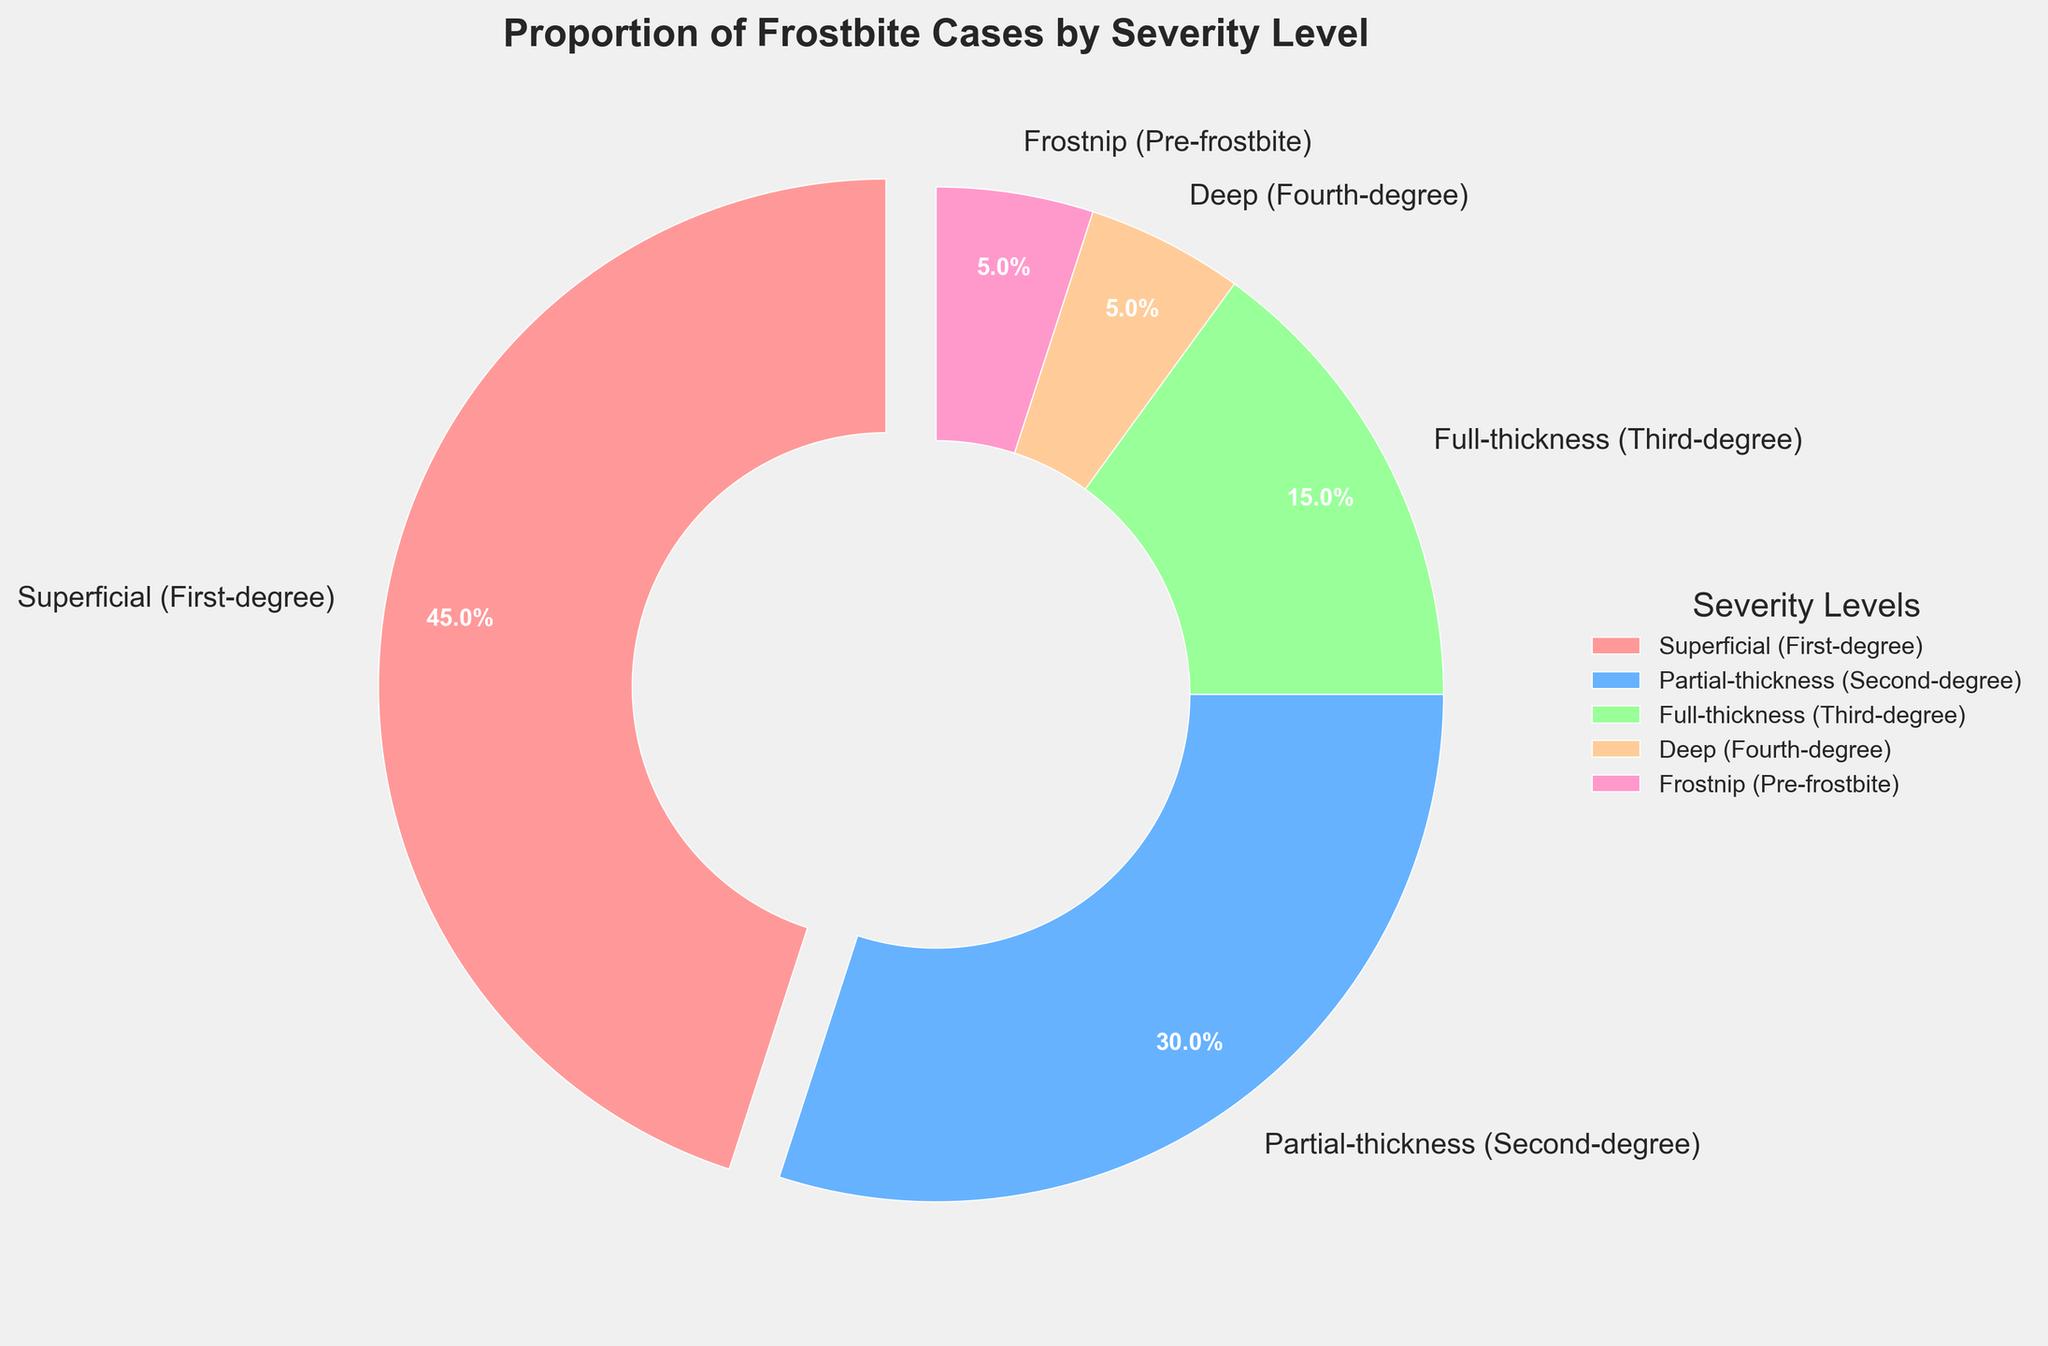What's the proportion of superficial frostbite cases? The superficial frostbite cases are represented by the largest slice on the pie chart, which is labeled as "Superficial (First-degree)" and occupies 45% of the pie.
Answer: 45% Which severity level has the smallest proportion of frostbite cases? According to the pie chart, the smallest slice corresponds to both "Deep (Fourth-degree)" and "Frostnip (Pre-frostbite)", each occupying 5%.
Answer: Deep (Fourth-degree) and Frostnip (Pre-frostbite) What is the combined percentage of superficial and partial-thickness frostbite cases? The superficial frostbite cases are 45% and partial-thickness cases are 30%. Adding these percentages together gives 45% + 30% = 75%.
Answer: 75% Which severity level has a larger proportion, full-thickness or deep frostbite? The pie chart shows that full-thickness frostbite occupies 15%, while deep frostbite occupies 5%. Therefore, full-thickness has a larger proportion.
Answer: Full-thickness frostbite What percentage of frostbite cases are more severe than second-degree frostbite? To find the cases more severe than second-degree, we add the percentages of full-thickness (15%) and deep frostbite (5%): 15% + 5% = 20%.
Answer: 20% What is the most common severity level of frostbite shown in the chart? The largest segment on the pie chart corresponds to "Superficial (First-degree)" frostbite, which is 45%, making it the most common severity level.
Answer: Superficial (First-degree) How much more common is superficial frostbite compared to deep frostbite? To find out how much more common superficial frostbite is compared to deep frostbite, we subtract the percentage of deep frostbite from superficial frostbite: 45% - 5% = 40%.
Answer: 40% Which severity levels combined make up exactly 50% of the frostbite cases? The segments representing partial-thickness (30%) and full-thickness (15%) frostbite sum up to 30% + 15% = 45%. Adding Frostnip (Pre-frostbite) which is 5%, the total is 45% + 5% = 50%.
Answer: Partial-thickness and Frostnip If you combine full-thickness, deep frostbite, and Frostnip, what percentage of the total frostbite cases do they represent? Adding the percentages of full-thickness (15%), deep frostbite (5%), and Frostnip (5%), we get 15% + 5% + 5% = 25%.
Answer: 25% What color represents partial-thickness frostbite in the pie chart? The color representing partial-thickness frostbite is the second segment, which appears as a shade of blue.
Answer: Blue 